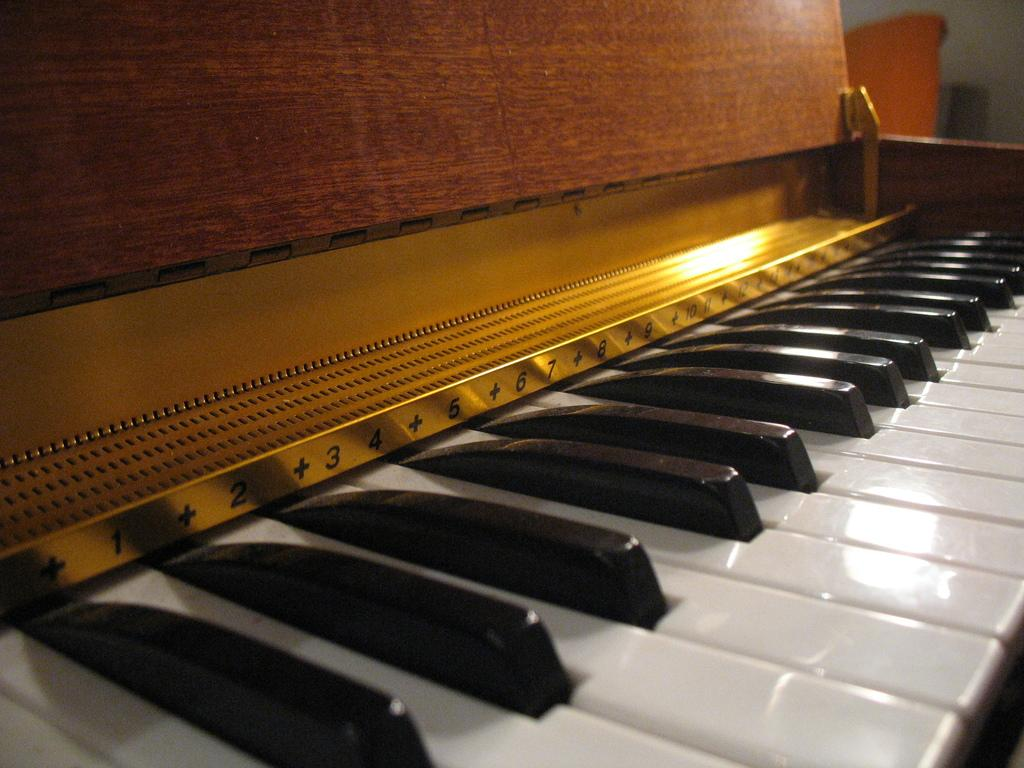What type of musical instrument is depicted in the image? The image features piano buttons, which are part of a piano. Can you describe the appearance of the piano buttons? The piano buttons are likely small, rectangular, and arranged in a specific pattern or layout. What might be the purpose of these piano buttons? The piano buttons are used to play different notes or chords when pressed. How much water can be seen flowing from the faucet in the image? There is no faucet present in the image; it features piano buttons. 